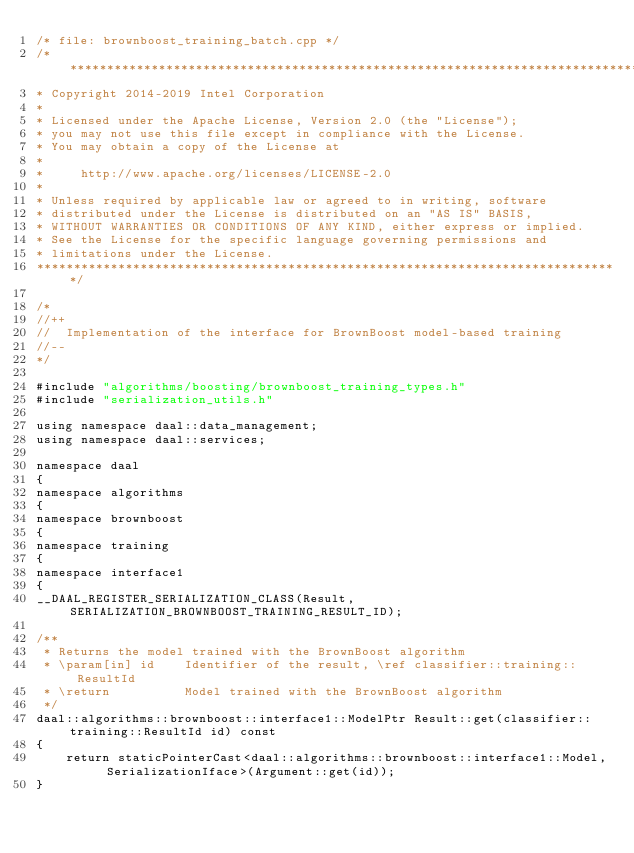Convert code to text. <code><loc_0><loc_0><loc_500><loc_500><_C++_>/* file: brownboost_training_batch.cpp */
/*******************************************************************************
* Copyright 2014-2019 Intel Corporation
*
* Licensed under the Apache License, Version 2.0 (the "License");
* you may not use this file except in compliance with the License.
* You may obtain a copy of the License at
*
*     http://www.apache.org/licenses/LICENSE-2.0
*
* Unless required by applicable law or agreed to in writing, software
* distributed under the License is distributed on an "AS IS" BASIS,
* WITHOUT WARRANTIES OR CONDITIONS OF ANY KIND, either express or implied.
* See the License for the specific language governing permissions and
* limitations under the License.
*******************************************************************************/

/*
//++
//  Implementation of the interface for BrownBoost model-based training
//--
*/

#include "algorithms/boosting/brownboost_training_types.h"
#include "serialization_utils.h"

using namespace daal::data_management;
using namespace daal::services;

namespace daal
{
namespace algorithms
{
namespace brownboost
{
namespace training
{
namespace interface1
{
__DAAL_REGISTER_SERIALIZATION_CLASS(Result, SERIALIZATION_BROWNBOOST_TRAINING_RESULT_ID);

/**
 * Returns the model trained with the BrownBoost algorithm
 * \param[in] id    Identifier of the result, \ref classifier::training::ResultId
 * \return          Model trained with the BrownBoost algorithm
 */
daal::algorithms::brownboost::interface1::ModelPtr Result::get(classifier::training::ResultId id) const
{
    return staticPointerCast<daal::algorithms::brownboost::interface1::Model, SerializationIface>(Argument::get(id));
}
</code> 